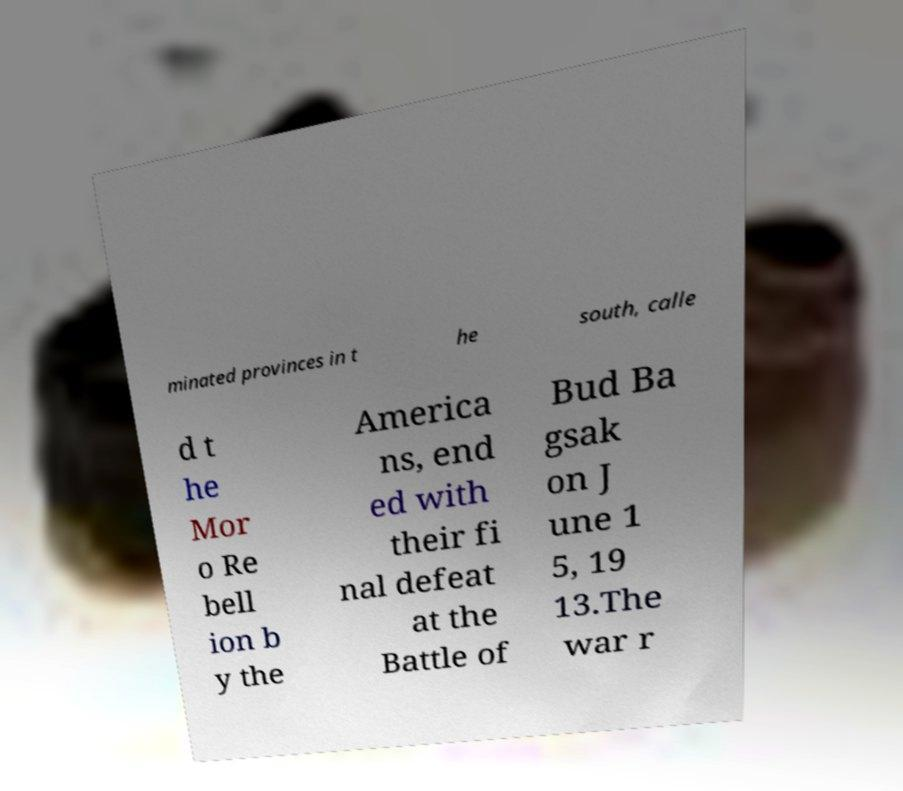Could you assist in decoding the text presented in this image and type it out clearly? minated provinces in t he south, calle d t he Mor o Re bell ion b y the America ns, end ed with their fi nal defeat at the Battle of Bud Ba gsak on J une 1 5, 19 13.The war r 